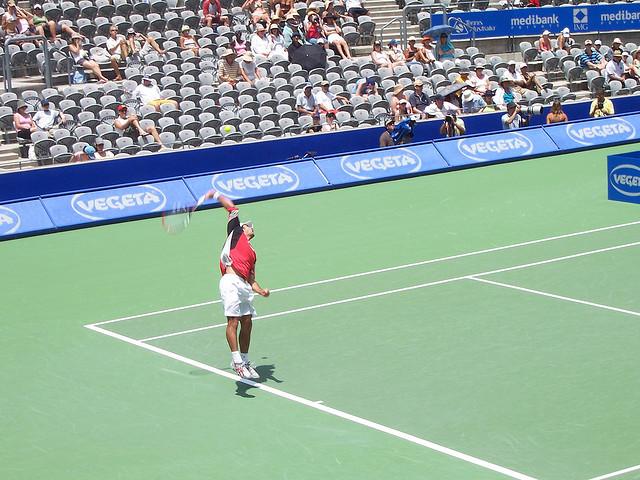What sponsor lines the court?
Answer briefly. Vegeta. What color is the man's shirt?
Short answer required. Red. What color is the court?
Write a very short answer. Green. What color is the tennis court?
Concise answer only. Green. Are all the seats filled?
Keep it brief. No. 